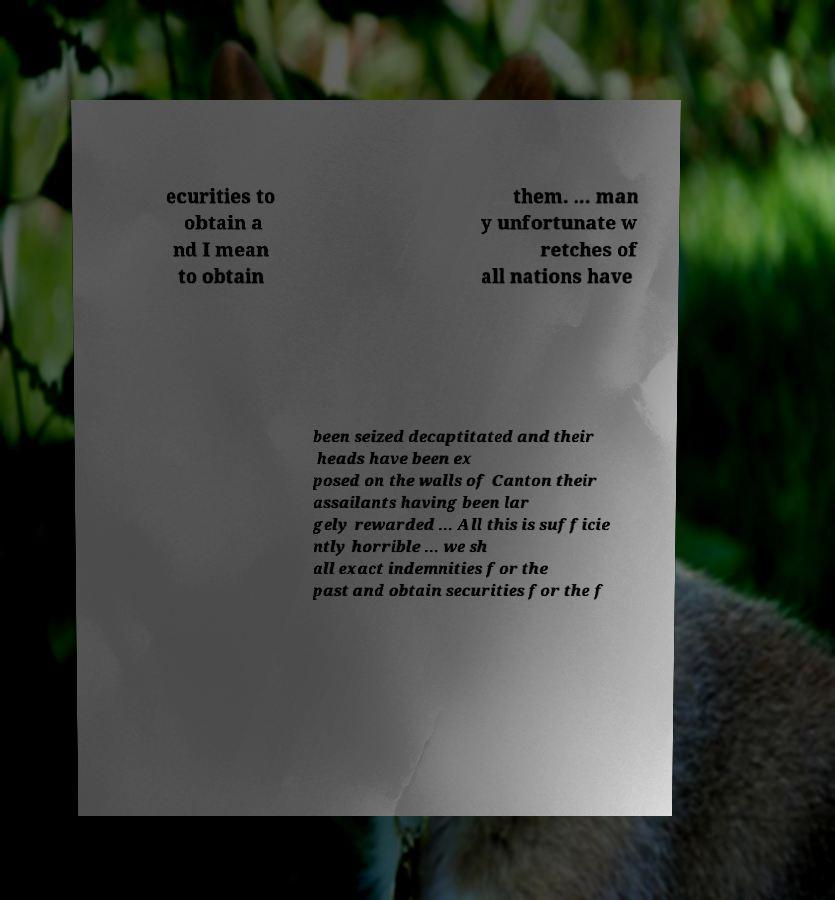What messages or text are displayed in this image? I need them in a readable, typed format. ecurities to obtain a nd I mean to obtain them. ... man y unfortunate w retches of all nations have been seized decaptitated and their heads have been ex posed on the walls of Canton their assailants having been lar gely rewarded ... All this is sufficie ntly horrible ... we sh all exact indemnities for the past and obtain securities for the f 